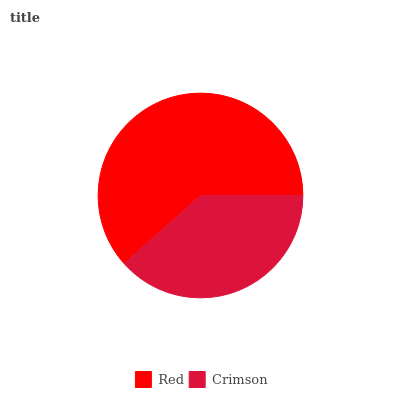Is Crimson the minimum?
Answer yes or no. Yes. Is Red the maximum?
Answer yes or no. Yes. Is Crimson the maximum?
Answer yes or no. No. Is Red greater than Crimson?
Answer yes or no. Yes. Is Crimson less than Red?
Answer yes or no. Yes. Is Crimson greater than Red?
Answer yes or no. No. Is Red less than Crimson?
Answer yes or no. No. Is Red the high median?
Answer yes or no. Yes. Is Crimson the low median?
Answer yes or no. Yes. Is Crimson the high median?
Answer yes or no. No. Is Red the low median?
Answer yes or no. No. 